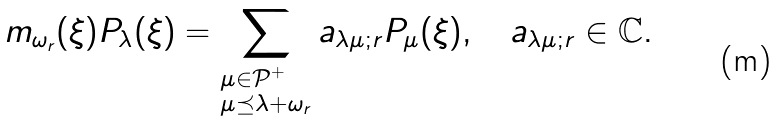<formula> <loc_0><loc_0><loc_500><loc_500>m _ { \omega _ { r } } ( \xi ) P _ { \lambda } ( \xi ) = \sum _ { \begin{subarray} { c } \mu \in \mathcal { P } ^ { + } \\ \mu \preceq \lambda + \omega _ { r } \end{subarray} } a _ { \lambda \mu ; r } P _ { \mu } ( \xi ) , \quad a _ { \lambda \mu ; r } \in \mathbb { C } .</formula> 